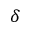<formula> <loc_0><loc_0><loc_500><loc_500>\delta</formula> 